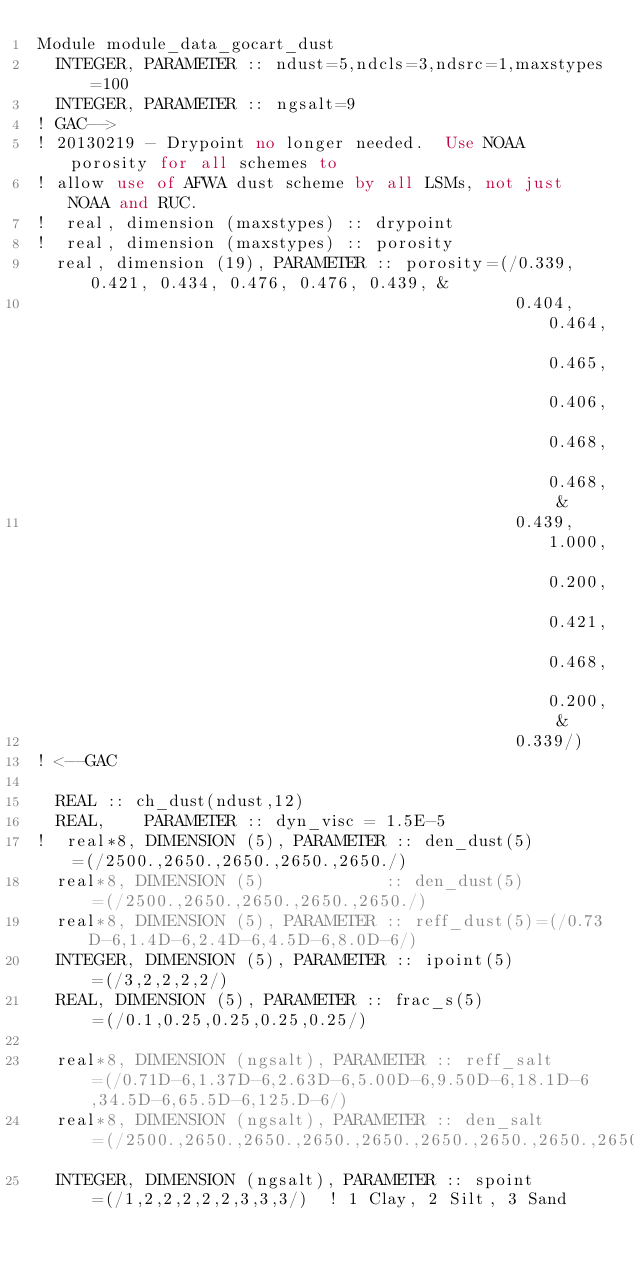<code> <loc_0><loc_0><loc_500><loc_500><_COBOL_>Module module_data_gocart_dust
  INTEGER, PARAMETER :: ndust=5,ndcls=3,ndsrc=1,maxstypes=100
  INTEGER, PARAMETER :: ngsalt=9
! GAC-->
! 20130219 - Drypoint no longer needed.  Use NOAA porosity for all schemes to
! allow use of AFWA dust scheme by all LSMs, not just NOAA and RUC.
!  real, dimension (maxstypes) :: drypoint
!  real, dimension (maxstypes) :: porosity
  real, dimension (19), PARAMETER :: porosity=(/0.339, 0.421, 0.434, 0.476, 0.476, 0.439, &
                                                0.404, 0.464, 0.465, 0.406, 0.468, 0.468, &
                                                0.439, 1.000, 0.200, 0.421, 0.468, 0.200, &
                                                0.339/)
! <--GAC

  REAL :: ch_dust(ndust,12)
  REAL,    PARAMETER :: dyn_visc = 1.5E-5
!  real*8, DIMENSION (5), PARAMETER :: den_dust(5)=(/2500.,2650.,2650.,2650.,2650./)
  real*8, DIMENSION (5)            :: den_dust(5)=(/2500.,2650.,2650.,2650.,2650./)
  real*8, DIMENSION (5), PARAMETER :: reff_dust(5)=(/0.73D-6,1.4D-6,2.4D-6,4.5D-6,8.0D-6/)
  INTEGER, DIMENSION (5), PARAMETER :: ipoint(5)=(/3,2,2,2,2/)
  REAL, DIMENSION (5), PARAMETER :: frac_s(5)=(/0.1,0.25,0.25,0.25,0.25/)

  real*8, DIMENSION (ngsalt), PARAMETER :: reff_salt=(/0.71D-6,1.37D-6,2.63D-6,5.00D-6,9.50D-6,18.1D-6,34.5D-6,65.5D-6,125.D-6/)
  real*8, DIMENSION (ngsalt), PARAMETER :: den_salt=(/2500.,2650.,2650.,2650.,2650.,2650.,2650.,2650.,2650./)
  INTEGER, DIMENSION (ngsalt), PARAMETER :: spoint=(/1,2,2,2,2,2,3,3,3/)  ! 1 Clay, 2 Silt, 3 Sand</code> 